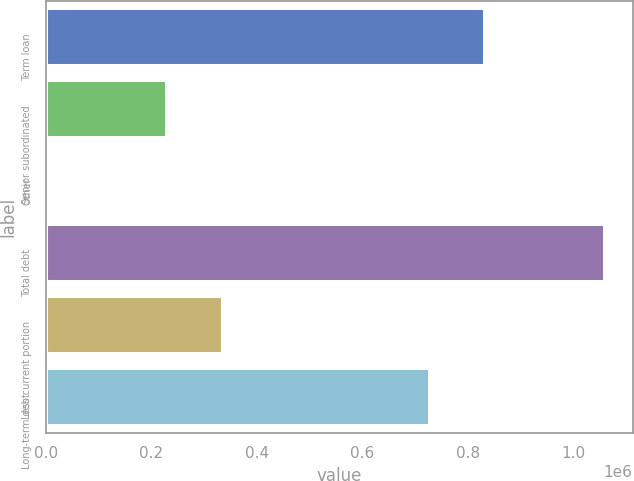Convert chart to OTSL. <chart><loc_0><loc_0><loc_500><loc_500><bar_chart><fcel>Term loan<fcel>Senior subordinated<fcel>Other<fcel>Total debt<fcel>Less current portion<fcel>Long-term debt<nl><fcel>832864<fcel>230000<fcel>4847<fcel>1.05859e+06<fcel>335374<fcel>727489<nl></chart> 